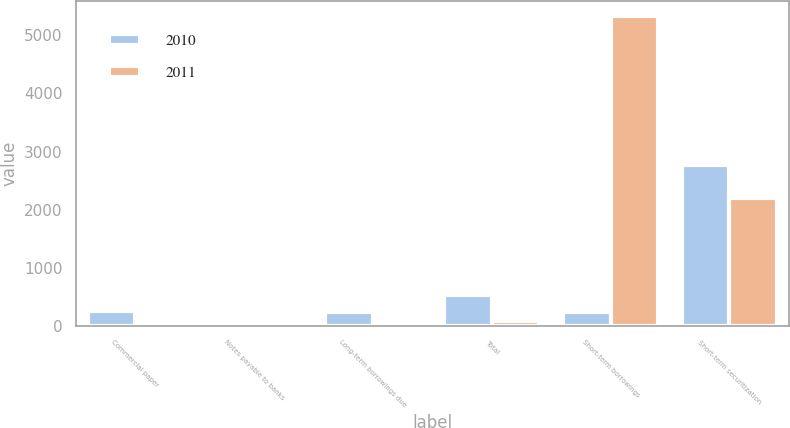Convert chart to OTSL. <chart><loc_0><loc_0><loc_500><loc_500><stacked_bar_chart><ecel><fcel>Commercial paper<fcel>Notes payable to banks<fcel>Long-term borrowings due<fcel>Total<fcel>Short-term borrowings<fcel>Short-term securitization<nl><fcel>2010<fcel>265<fcel>19<fcel>244<fcel>528<fcel>244<fcel>2777<nl><fcel>2011<fcel>37<fcel>8<fcel>40<fcel>85<fcel>5326<fcel>2209<nl></chart> 